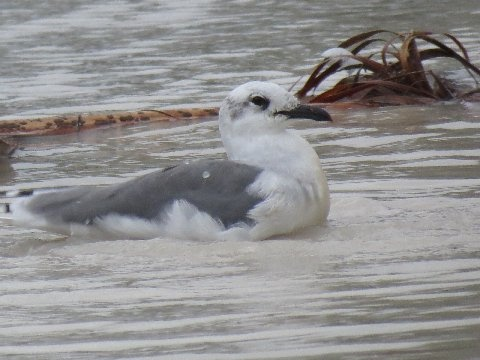Describe the objects in this image and their specific colors. I can see a bird in gray and darkgray tones in this image. 